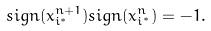<formula> <loc_0><loc_0><loc_500><loc_500>s i g n ( x _ { i ^ { * } } ^ { n + 1 } ) s i g n ( x _ { i ^ { * } } ^ { n } ) = - 1 .</formula> 